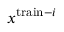<formula> <loc_0><loc_0><loc_500><loc_500>x ^ { t r a i n - i }</formula> 